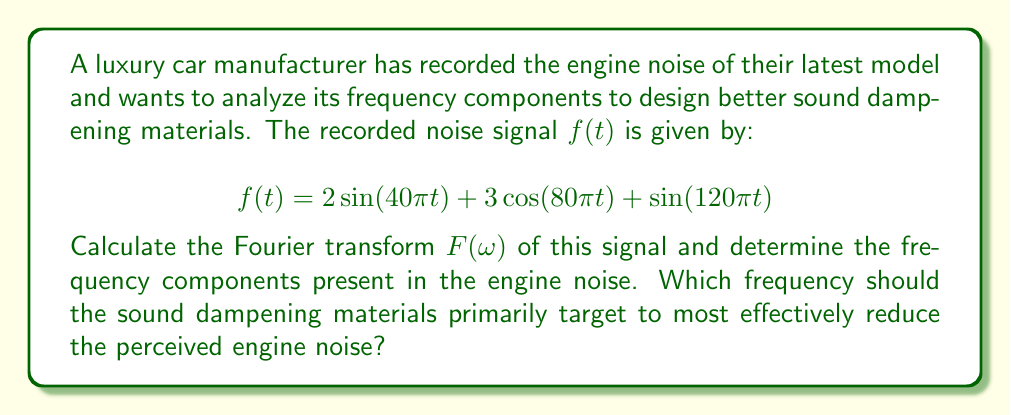Give your solution to this math problem. To solve this problem, we need to follow these steps:

1) The Fourier transform of a sinusoidal function is given by:

   $$\mathcal{F}\{A\sin(\omega_0 t)\} = i\pi A[\delta(\omega + \omega_0) - \delta(\omega - \omega_0)]$$
   $$\mathcal{F}\{A\cos(\omega_0 t)\} = \pi A[\delta(\omega + \omega_0) + \delta(\omega - \omega_0)]$$

2) Let's calculate the Fourier transform of each component:

   For $2\sin(40\pi t)$:
   $$\mathcal{F}\{2\sin(40\pi t)\} = 2\pi i[\delta(\omega + 40\pi) - \delta(\omega - 40\pi)]$$

   For $3\cos(80\pi t)$:
   $$\mathcal{F}\{3\cos(80\pi t)\} = 3\pi[\delta(\omega + 80\pi) + \delta(\omega - 80\pi)]$$

   For $\sin(120\pi t)$:
   $$\mathcal{F}\{\sin(120\pi t)\} = \pi i[\delta(\omega + 120\pi) - \delta(\omega - 120\pi)]$$

3) The total Fourier transform $F(\omega)$ is the sum of these components:

   $$F(\omega) = 2\pi i[\delta(\omega + 40\pi) - \delta(\omega - 40\pi)] + 3\pi[\delta(\omega + 80\pi) + \delta(\omega - 80\pi)] + \pi i[\delta(\omega + 120\pi) - \delta(\omega - 120\pi)]$$

4) From this, we can identify the frequency components:
   - 20 Hz (from the 40π term)
   - 40 Hz (from the 80π term)
   - 60 Hz (from the 120π term)

5) To determine which frequency to target, we need to consider both the amplitude and the human ear's sensitivity. The 40 Hz component has the largest amplitude (3), and it's in a range where the human ear is quite sensitive. Therefore, this should be the primary target for sound dampening.
Answer: The Fourier transform of the signal is:

$$F(\omega) = 2\pi i[\delta(\omega + 40\pi) - \delta(\omega - 40\pi)] + 3\pi[\delta(\omega + 80\pi) + \delta(\omega - 80\pi)] + \pi i[\delta(\omega + 120\pi) - \delta(\omega - 120\pi)]$$

The frequency components are 20 Hz, 40 Hz, and 60 Hz. The sound dampening materials should primarily target the 40 Hz frequency to most effectively reduce the perceived engine noise. 